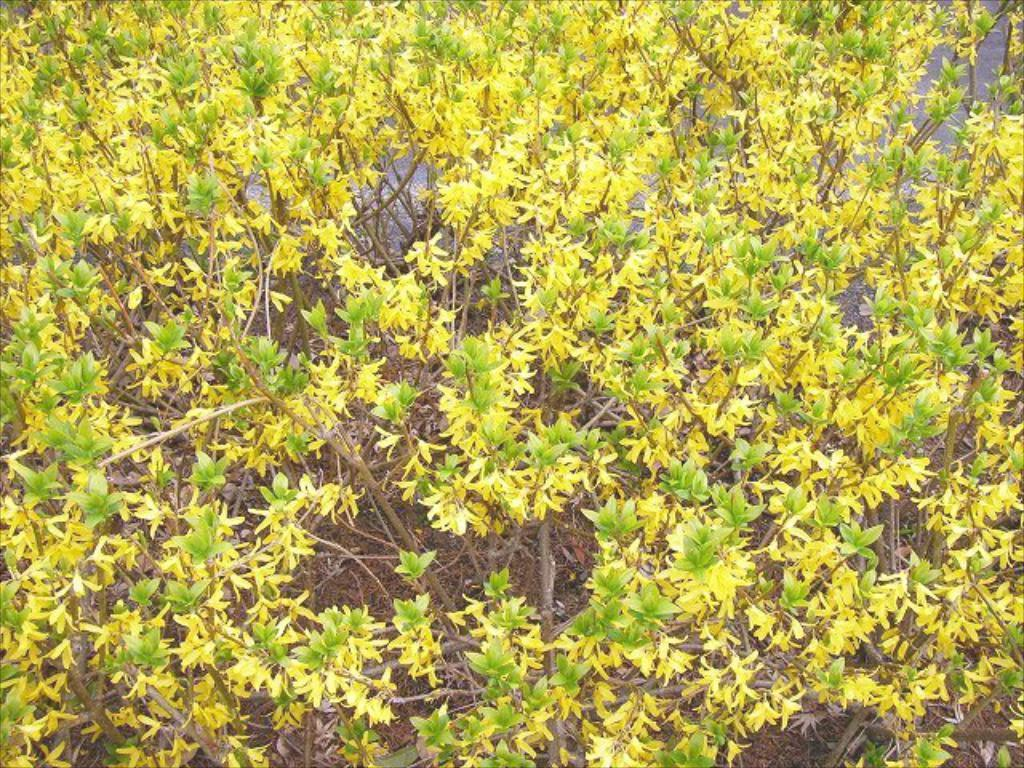What type of living organisms can be seen in the image? Plants can be seen in the image. What part of the plant is visible in the image? Leaves are visible in the image. What role does the tiger play in the image? A: There is no tiger present in the image. What is the purpose of the actor in the image? There is no actor present in the image. 